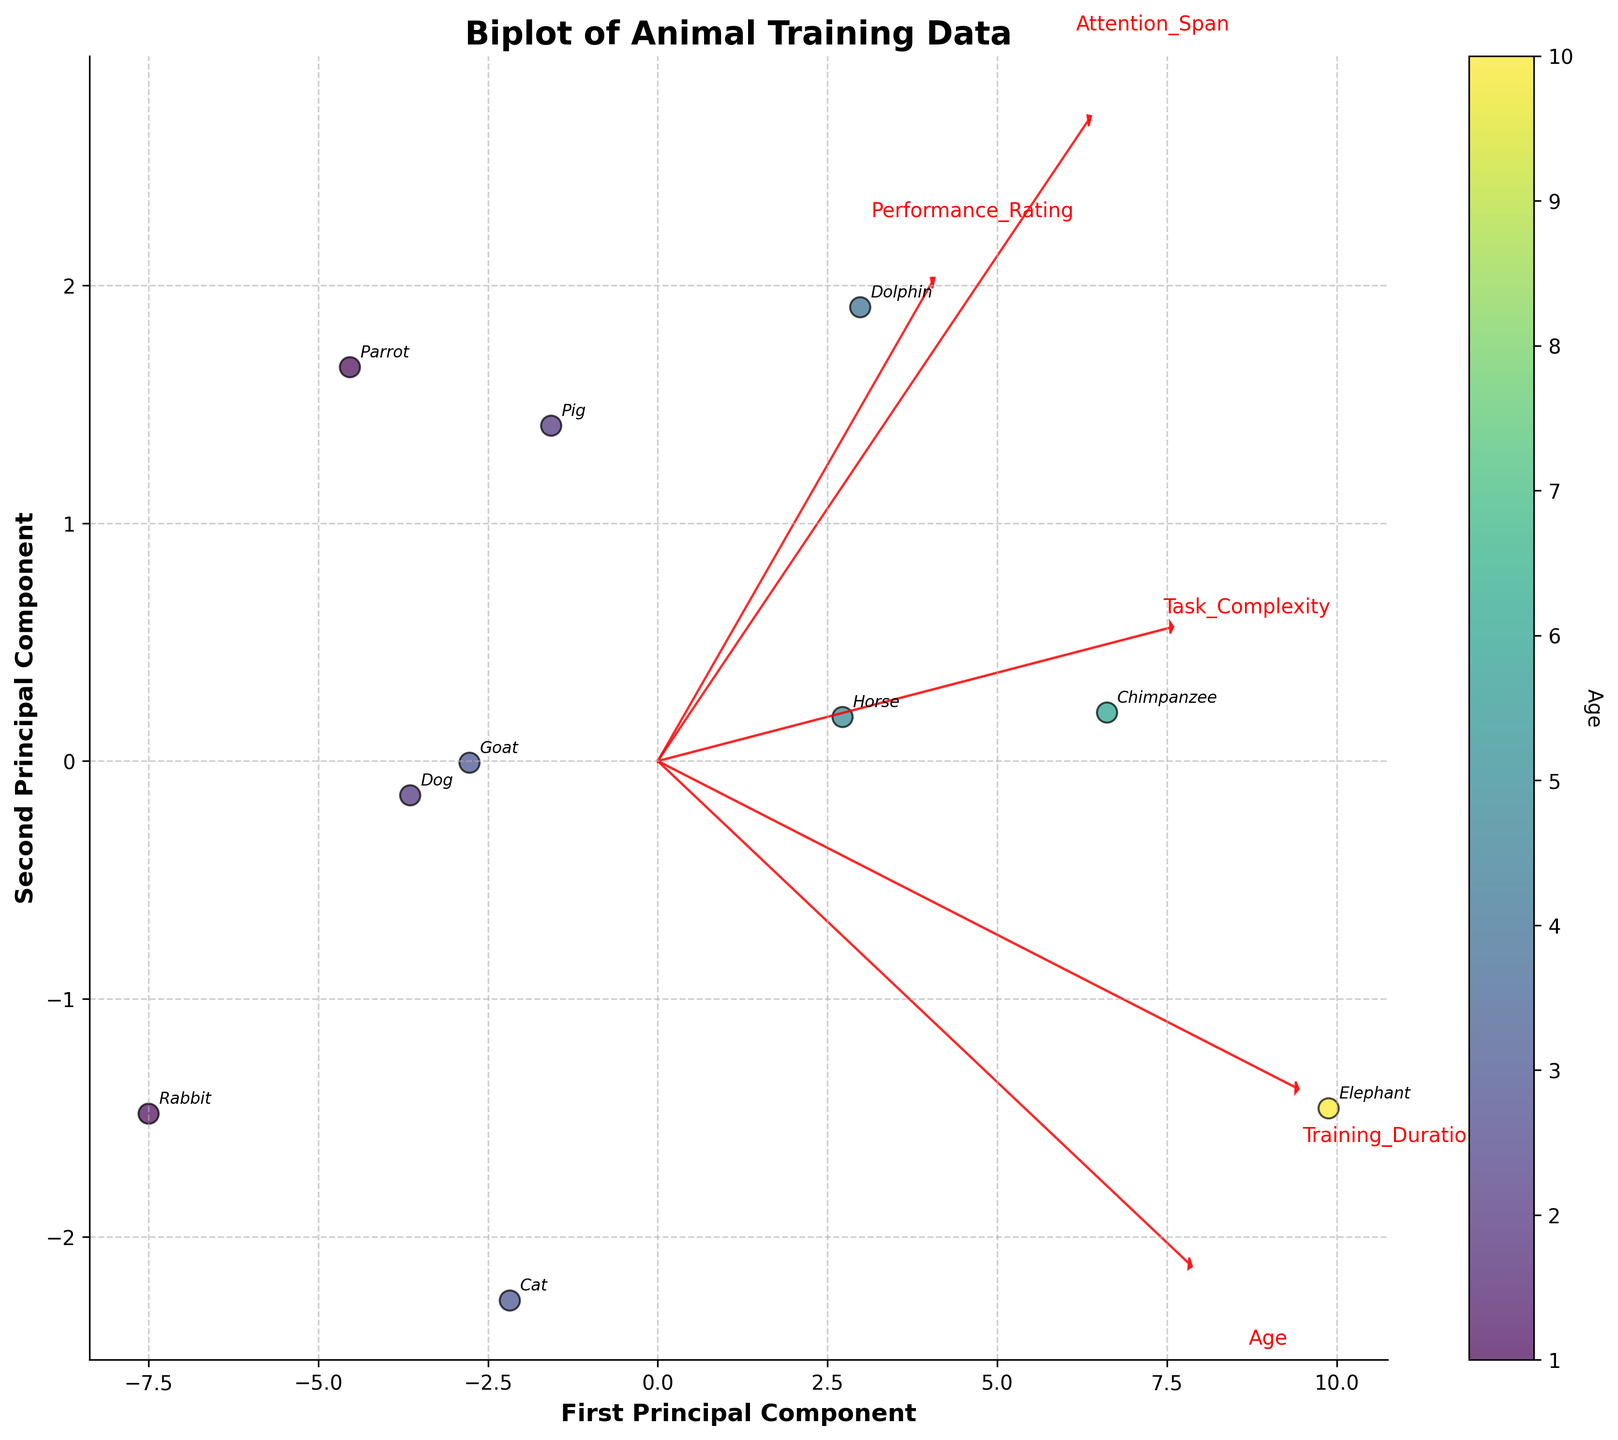How many animals are represented in the scatter plot? The plot annotations show the names of each animal shown in different points. Counting these individual labels gives the total number of animals.
Answer: 10 What are the labels on the axes of the biplot? The labels of the axes are written along the x-axis and y-axis. The x-axis is labeled "First Principal Component" and the y-axis is labeled "Second Principal Component".
Answer: First Principal Component, Second Principal Component Which animal appears to have the highest age? Looking at the scatter plot, the color of the points indicates the age based on the color bar. The animal with the point colored closest to the highest value on the color bar represents the oldest age, which appears to be the elephant.
Answer: Elephant Which two variables have the highest relationship in training tasks for animals? By examining the lengths of the arrows representing the feature vectors, the longest arrows tend to have the highest relationship with the first two principal components. The variables "Age" and "Training_Duration" have the longest vectors.
Answer: Age and Training_Duration What color corresponds to the youngest animals on the color bar? The color bar indicates the age of the animals, with the lighter colors corresponding to younger ages. The youngest age should be at the low end of the color bar, which is yellow.
Answer: Yellow Which animal required the shortest training duration? The animals’ points are annotated and their positions are plotted according to their principal components. The point with the lowest training duration can be identified from the arrangement of principal components. Rabbit has the shortest training duration.
Answer: Rabbit Which task complexity has a closer relationship to "Attention_Span" or "Age"? Vectors pointing in almost the same direction indicate closely related variables. The arrows for Task Complexity and Attention Span are more aligned compared to Task Complexity and Age.
Answer: Attention_Span Which animals are annotated at the bottom-left quadrant? The annotations of animals in the scatter plot indicate their positions. The bottom-left quadrant of the plot includes the animals Rabbit and Parrot.
Answer: Rabbit and Parrot Which variable has the weakest influence on the second principal component? The length of the feature vectors along the second principal component's axis determines the influence. The variable with the shortest arrow in the vertical direction, which is Attention_Span, has the weakest influence.
Answer: Attention_Span 